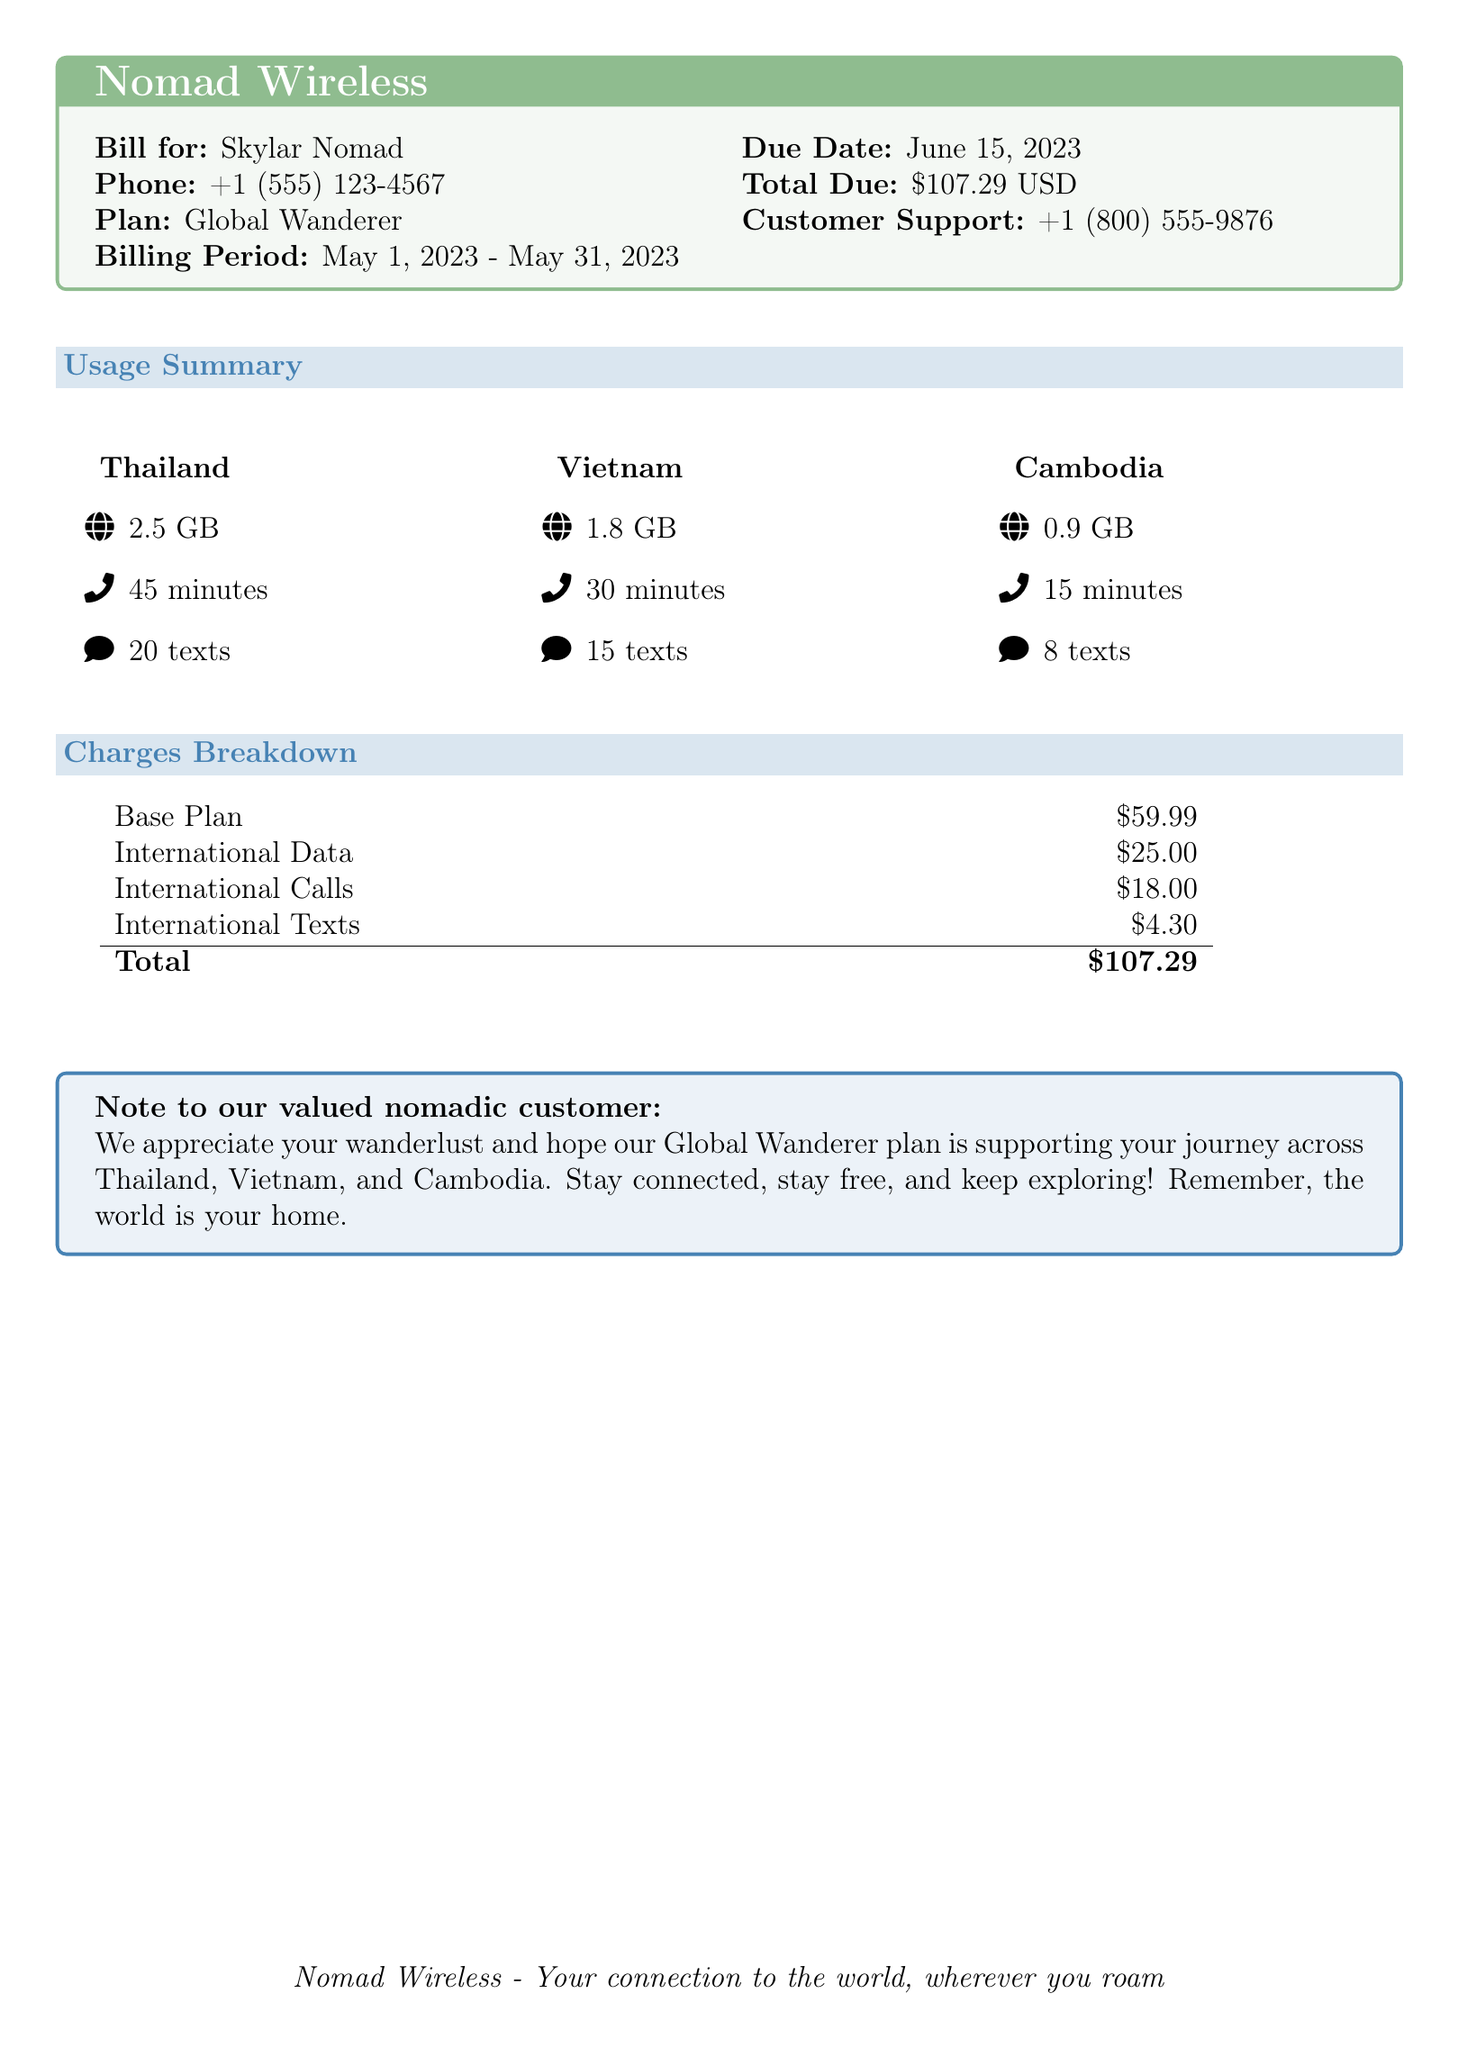What is the billing period? The billing period is specified in the document as May 1, 2023 - May 31, 2023.
Answer: May 1, 2023 - May 31, 2023 What is the total due amount? The total due amount is clearly mentioned in the document as \$107.29 USD.
Answer: \$107.29 USD How many texts were sent from Thailand? The number of texts sent from Thailand is listed in the usage summary as 20 texts.
Answer: 20 texts What is the charge for international calls? The charge for international calls is detailed in the charges breakdown as \$18.00.
Answer: \$18.00 Which country had the highest data usage? The highest data usage is for Thailand, listed as 2.5 GB, compared to the other countries.
Answer: Thailand What is the phone number for customer support? The customer support phone number is provided in the document as +1 (800) 555-9876.
Answer: +1 (800) 555-9876 What plan is being used? The plan being used is indicated as Global Wanderer in the document.
Answer: Global Wanderer How many minutes were used in Cambodia? The usage summary states that 15 minutes were used in Cambodia.
Answer: 15 minutes What is the base plan charge? The document specifies the base plan charge as \$59.99.
Answer: \$59.99 